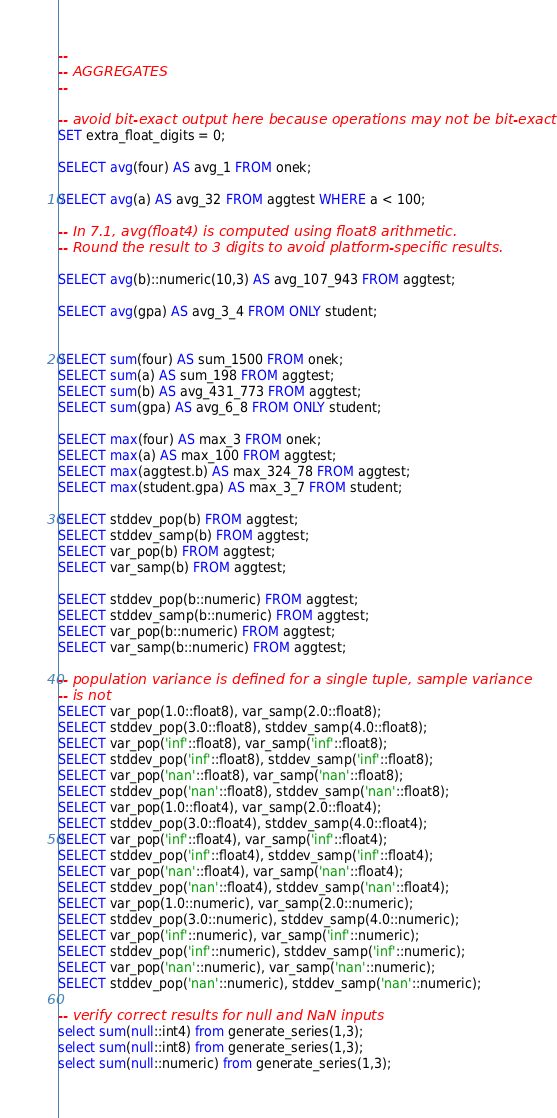Convert code to text. <code><loc_0><loc_0><loc_500><loc_500><_SQL_>--
-- AGGREGATES
--

-- avoid bit-exact output here because operations may not be bit-exact.
SET extra_float_digits = 0;

SELECT avg(four) AS avg_1 FROM onek;

SELECT avg(a) AS avg_32 FROM aggtest WHERE a < 100;

-- In 7.1, avg(float4) is computed using float8 arithmetic.
-- Round the result to 3 digits to avoid platform-specific results.

SELECT avg(b)::numeric(10,3) AS avg_107_943 FROM aggtest;

SELECT avg(gpa) AS avg_3_4 FROM ONLY student;


SELECT sum(four) AS sum_1500 FROM onek;
SELECT sum(a) AS sum_198 FROM aggtest;
SELECT sum(b) AS avg_431_773 FROM aggtest;
SELECT sum(gpa) AS avg_6_8 FROM ONLY student;

SELECT max(four) AS max_3 FROM onek;
SELECT max(a) AS max_100 FROM aggtest;
SELECT max(aggtest.b) AS max_324_78 FROM aggtest;
SELECT max(student.gpa) AS max_3_7 FROM student;

SELECT stddev_pop(b) FROM aggtest;
SELECT stddev_samp(b) FROM aggtest;
SELECT var_pop(b) FROM aggtest;
SELECT var_samp(b) FROM aggtest;

SELECT stddev_pop(b::numeric) FROM aggtest;
SELECT stddev_samp(b::numeric) FROM aggtest;
SELECT var_pop(b::numeric) FROM aggtest;
SELECT var_samp(b::numeric) FROM aggtest;

-- population variance is defined for a single tuple, sample variance
-- is not
SELECT var_pop(1.0::float8), var_samp(2.0::float8);
SELECT stddev_pop(3.0::float8), stddev_samp(4.0::float8);
SELECT var_pop('inf'::float8), var_samp('inf'::float8);
SELECT stddev_pop('inf'::float8), stddev_samp('inf'::float8);
SELECT var_pop('nan'::float8), var_samp('nan'::float8);
SELECT stddev_pop('nan'::float8), stddev_samp('nan'::float8);
SELECT var_pop(1.0::float4), var_samp(2.0::float4);
SELECT stddev_pop(3.0::float4), stddev_samp(4.0::float4);
SELECT var_pop('inf'::float4), var_samp('inf'::float4);
SELECT stddev_pop('inf'::float4), stddev_samp('inf'::float4);
SELECT var_pop('nan'::float4), var_samp('nan'::float4);
SELECT stddev_pop('nan'::float4), stddev_samp('nan'::float4);
SELECT var_pop(1.0::numeric), var_samp(2.0::numeric);
SELECT stddev_pop(3.0::numeric), stddev_samp(4.0::numeric);
SELECT var_pop('inf'::numeric), var_samp('inf'::numeric);
SELECT stddev_pop('inf'::numeric), stddev_samp('inf'::numeric);
SELECT var_pop('nan'::numeric), var_samp('nan'::numeric);
SELECT stddev_pop('nan'::numeric), stddev_samp('nan'::numeric);

-- verify correct results for null and NaN inputs
select sum(null::int4) from generate_series(1,3);
select sum(null::int8) from generate_series(1,3);
select sum(null::numeric) from generate_series(1,3);</code> 